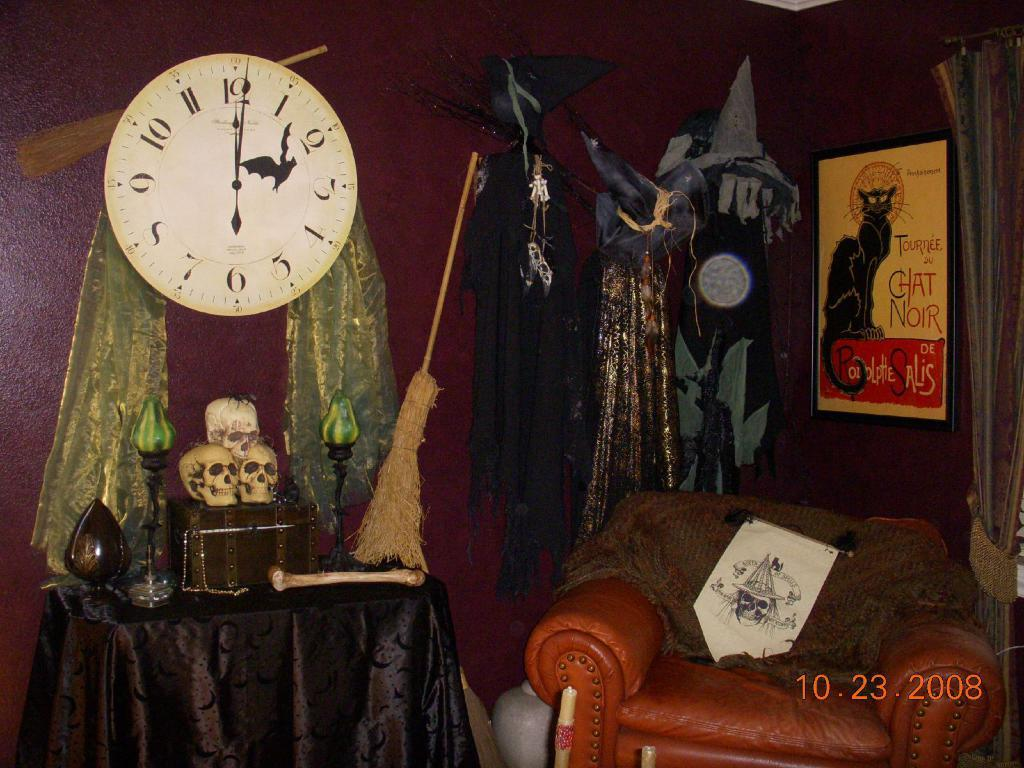<image>
Summarize the visual content of the image. a spooky room has a large clock that says 12:01 